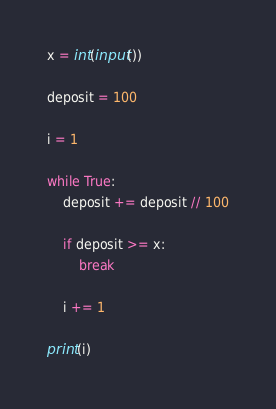Convert code to text. <code><loc_0><loc_0><loc_500><loc_500><_Python_>x = int(input())

deposit = 100

i = 1

while True:
    deposit += deposit // 100

    if deposit >= x:
        break

    i += 1

print(i)
</code> 